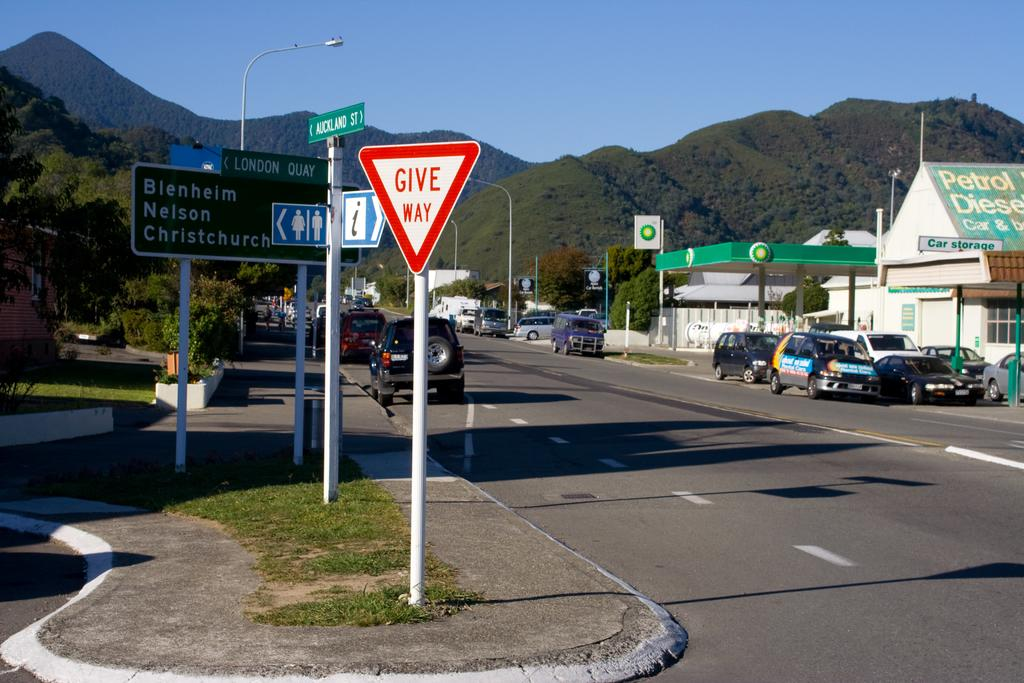<image>
Share a concise interpretation of the image provided. a Give Way sign in a median of a road side 